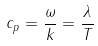<formula> <loc_0><loc_0><loc_500><loc_500>c _ { p } = \frac { \omega } { k } = \frac { \lambda } { T }</formula> 